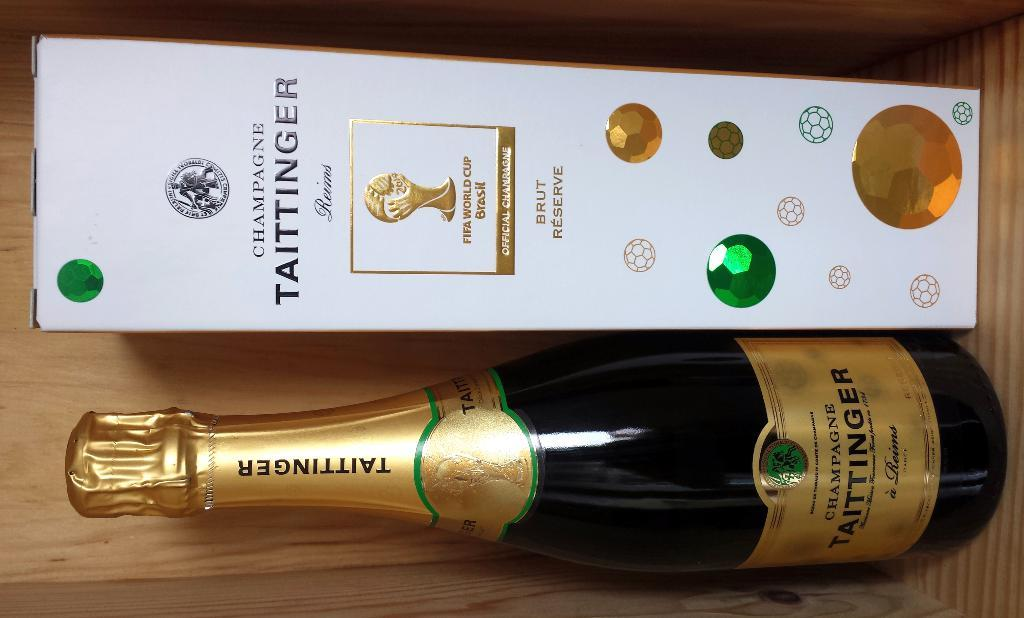<image>
Describe the image concisely. A wine bottle called TAITTINGER with a white box next to it 